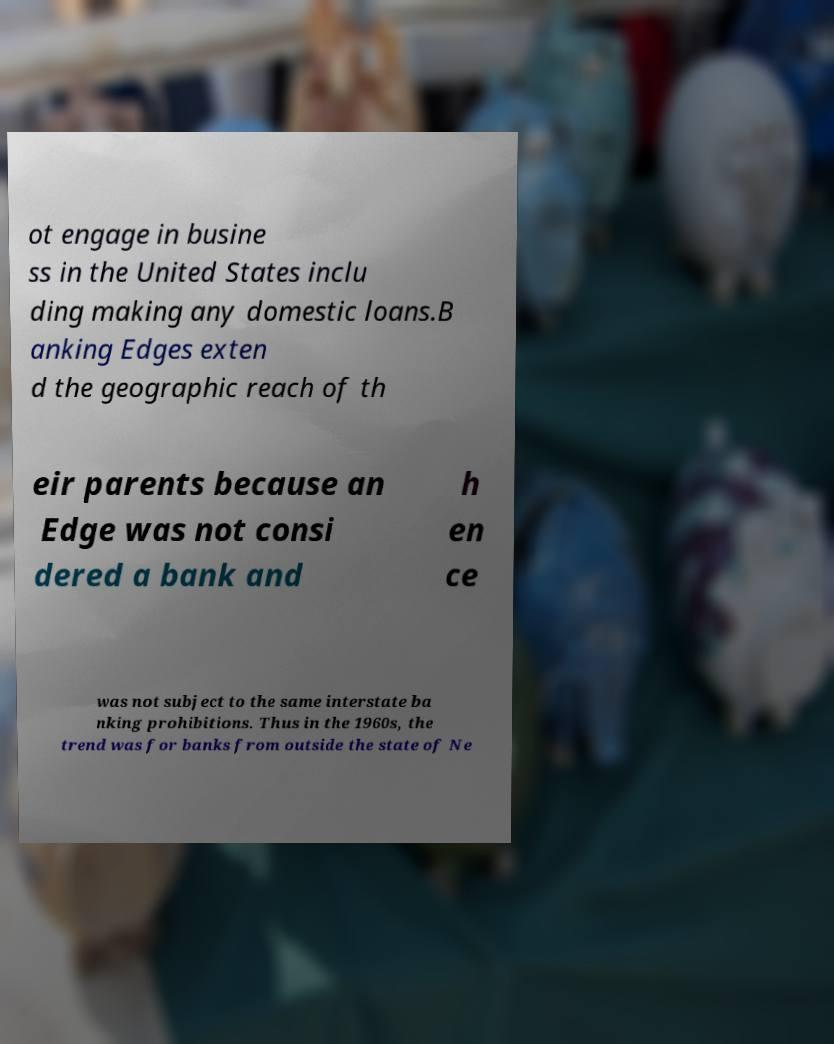Could you assist in decoding the text presented in this image and type it out clearly? ot engage in busine ss in the United States inclu ding making any domestic loans.B anking Edges exten d the geographic reach of th eir parents because an Edge was not consi dered a bank and h en ce was not subject to the same interstate ba nking prohibitions. Thus in the 1960s, the trend was for banks from outside the state of Ne 